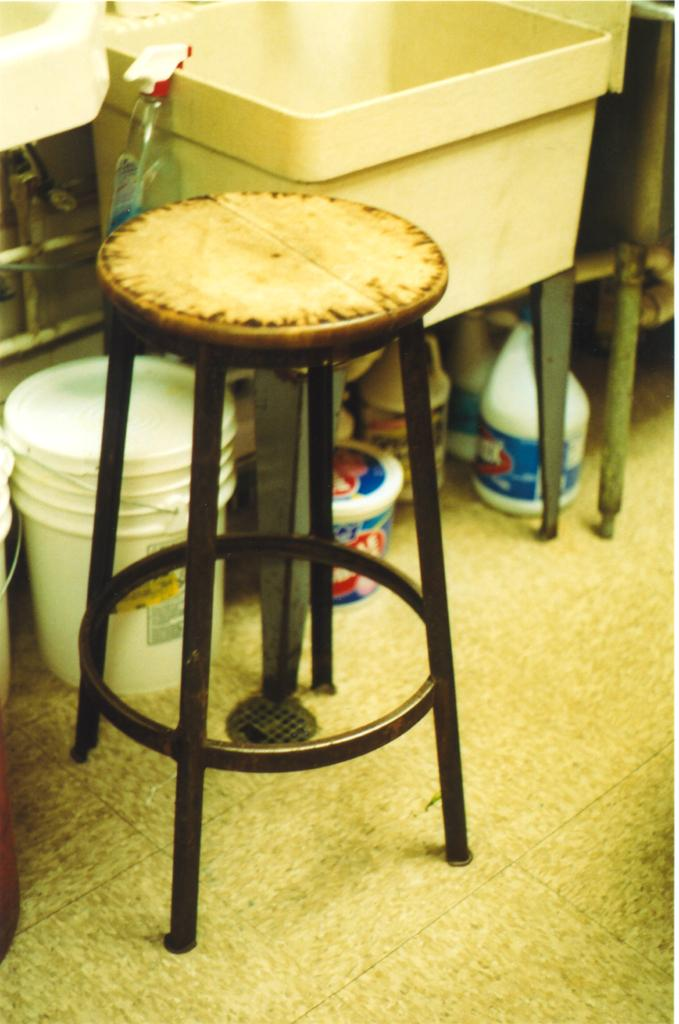What type of furniture is in the image? There is a stool in the image. What cleaning product is visible in the image? There is a cleanser bottle in the image. What type of containers are in the image? There are buckets in the image. What type of storage items are in the image? There are boxes in the image. What is on the floor in the image? There are items on the floor in the image. How does the queen express her hate for the shoe in the image? There is no queen, hate, or shoe present in the image. 